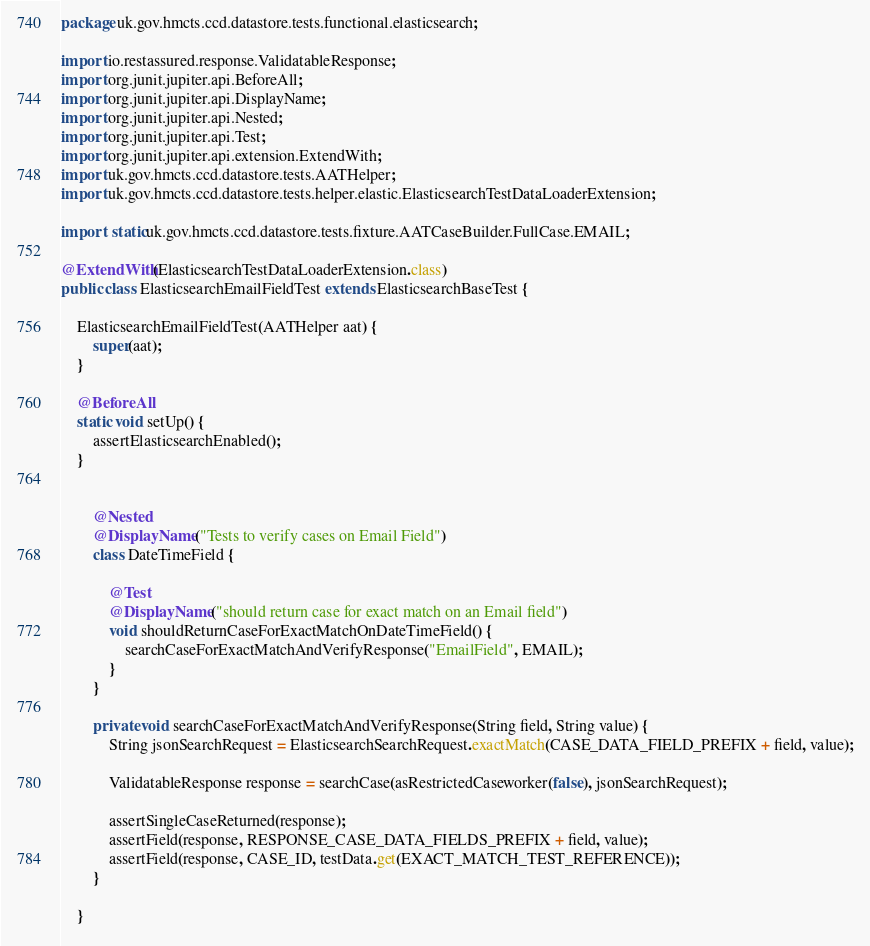Convert code to text. <code><loc_0><loc_0><loc_500><loc_500><_Java_>package uk.gov.hmcts.ccd.datastore.tests.functional.elasticsearch;

import io.restassured.response.ValidatableResponse;
import org.junit.jupiter.api.BeforeAll;
import org.junit.jupiter.api.DisplayName;
import org.junit.jupiter.api.Nested;
import org.junit.jupiter.api.Test;
import org.junit.jupiter.api.extension.ExtendWith;
import uk.gov.hmcts.ccd.datastore.tests.AATHelper;
import uk.gov.hmcts.ccd.datastore.tests.helper.elastic.ElasticsearchTestDataLoaderExtension;

import static uk.gov.hmcts.ccd.datastore.tests.fixture.AATCaseBuilder.FullCase.EMAIL;

@ExtendWith(ElasticsearchTestDataLoaderExtension.class)
public class ElasticsearchEmailFieldTest extends ElasticsearchBaseTest {

    ElasticsearchEmailFieldTest(AATHelper aat) {
        super(aat);
    }

    @BeforeAll
    static void setUp() {
        assertElasticsearchEnabled();
    }


        @Nested
        @DisplayName("Tests to verify cases on Email Field")
        class DateTimeField {

            @Test
            @DisplayName("should return case for exact match on an Email field")
            void shouldReturnCaseForExactMatchOnDateTimeField() {
                searchCaseForExactMatchAndVerifyResponse("EmailField", EMAIL);
            }
        }

        private void searchCaseForExactMatchAndVerifyResponse(String field, String value) {
            String jsonSearchRequest = ElasticsearchSearchRequest.exactMatch(CASE_DATA_FIELD_PREFIX + field, value);

            ValidatableResponse response = searchCase(asRestrictedCaseworker(false), jsonSearchRequest);

            assertSingleCaseReturned(response);
            assertField(response, RESPONSE_CASE_DATA_FIELDS_PREFIX + field, value);
            assertField(response, CASE_ID, testData.get(EXACT_MATCH_TEST_REFERENCE));
        }

    }



</code> 